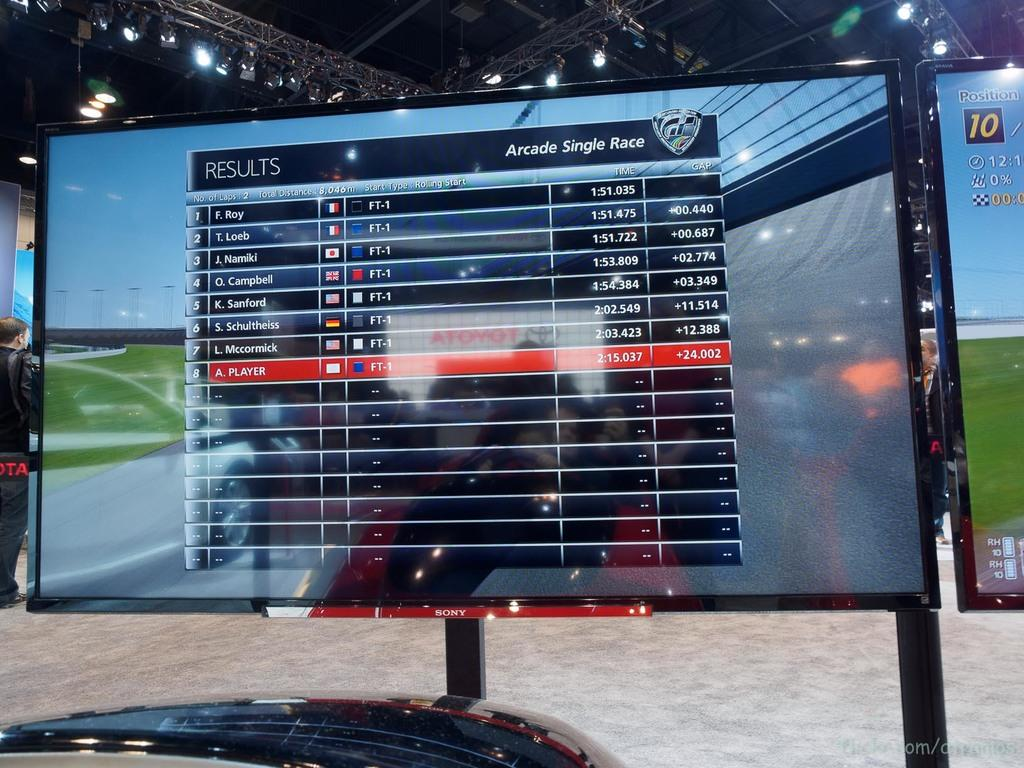<image>
Write a terse but informative summary of the picture. The board showing results for the Single Race Arcade 